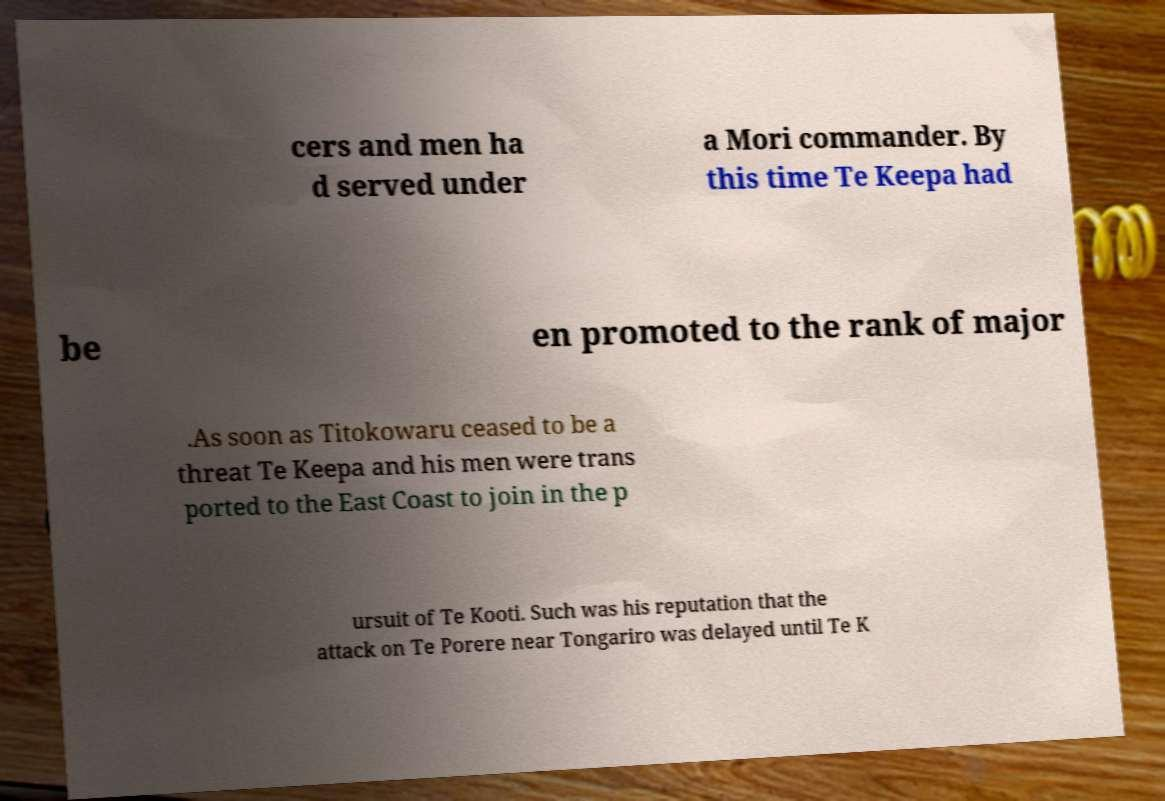Please read and relay the text visible in this image. What does it say? cers and men ha d served under a Mori commander. By this time Te Keepa had be en promoted to the rank of major .As soon as Titokowaru ceased to be a threat Te Keepa and his men were trans ported to the East Coast to join in the p ursuit of Te Kooti. Such was his reputation that the attack on Te Porere near Tongariro was delayed until Te K 